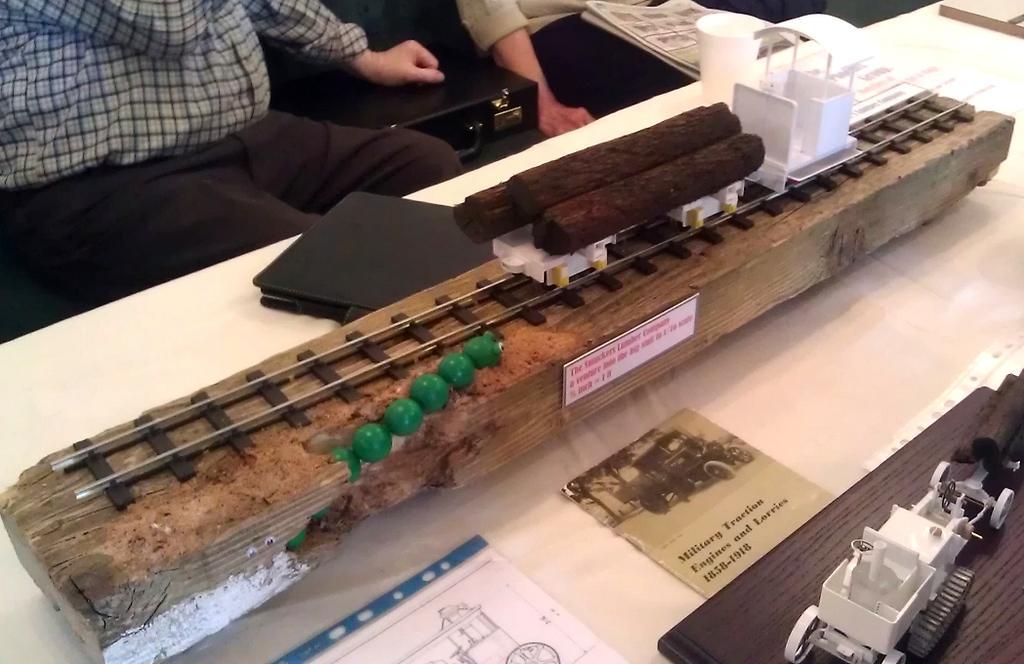Describe this image in one or two sentences. Here we can see that a bamboo stick on the table and papers and some other objects on it,and in front her is the person sitting, and at beside there is the briefcase. 